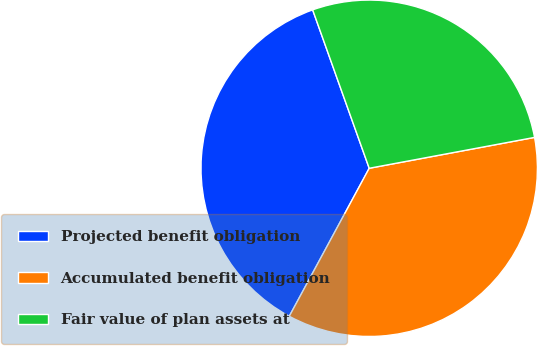Convert chart to OTSL. <chart><loc_0><loc_0><loc_500><loc_500><pie_chart><fcel>Projected benefit obligation<fcel>Accumulated benefit obligation<fcel>Fair value of plan assets at<nl><fcel>36.66%<fcel>35.82%<fcel>27.52%<nl></chart> 